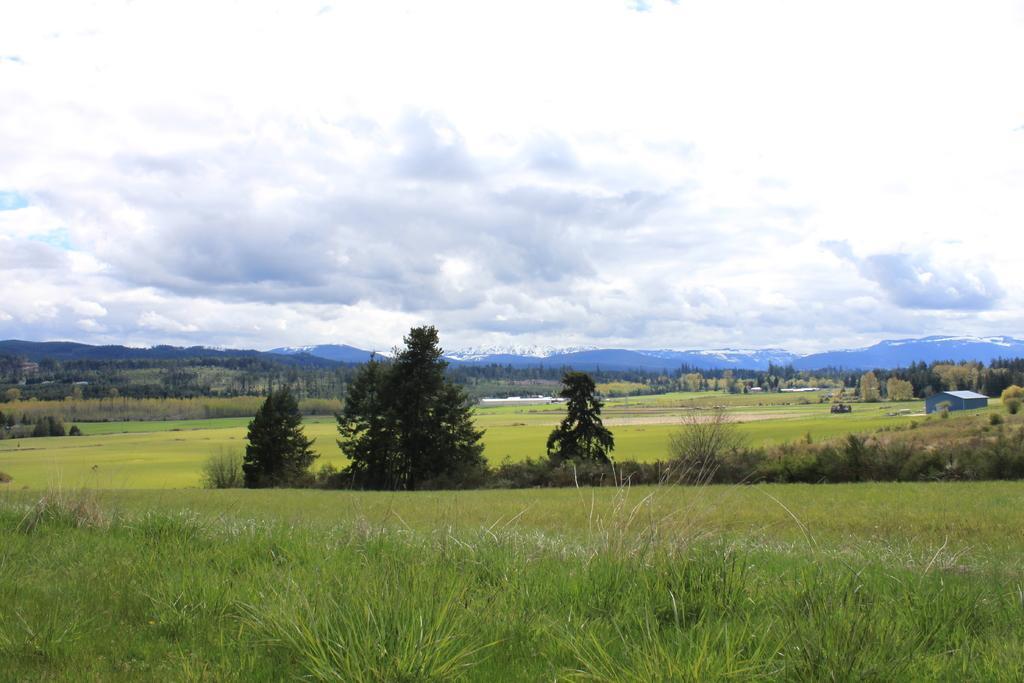In one or two sentences, can you explain what this image depicts? In this picture we can see some grass on the found visible from left to right. There are a few trees. We can see a house, bushes, trees and mountains covered with snow in the background. Sky is cloudy. 